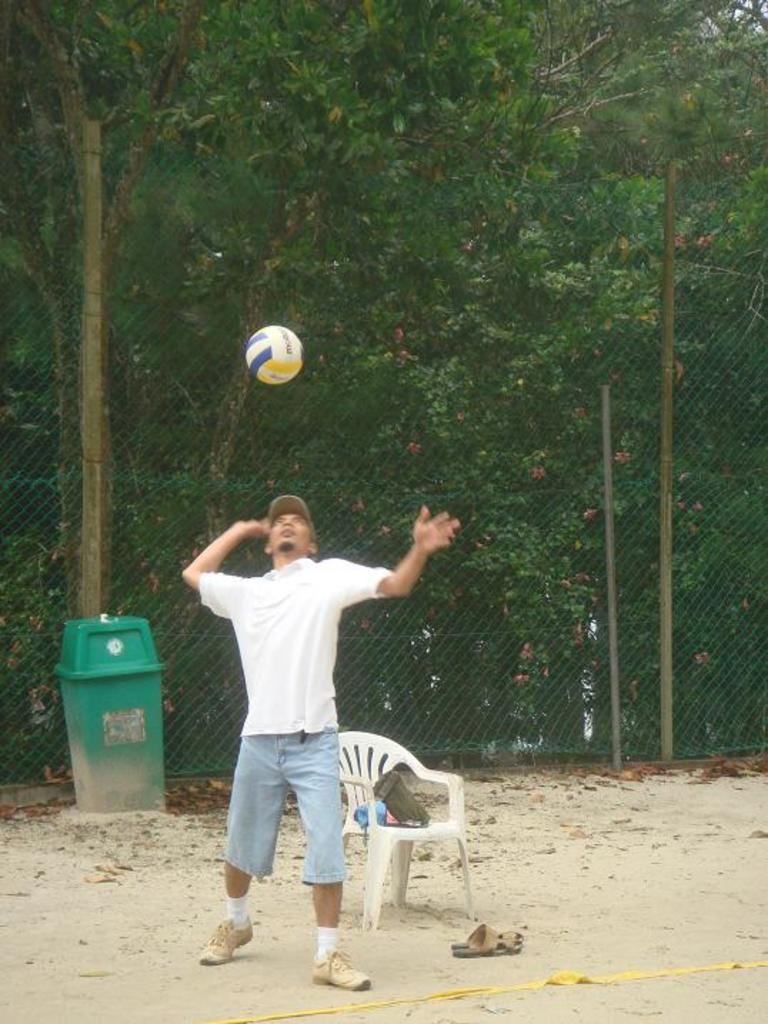Who is present in the image? There is a man in the image. What is the man doing in the image? The man is playing with a ball. What piece of furniture can be seen in the image? There is a chair in the image. What can be seen in the background of the image? There is a fence and trees in the background of the image. What type of container is present in the image? There is a bin in the image. Can you tell me how many times the man breathes in the image? It is not possible to determine the number of breaths the man takes in the image, as it is a still photograph. 